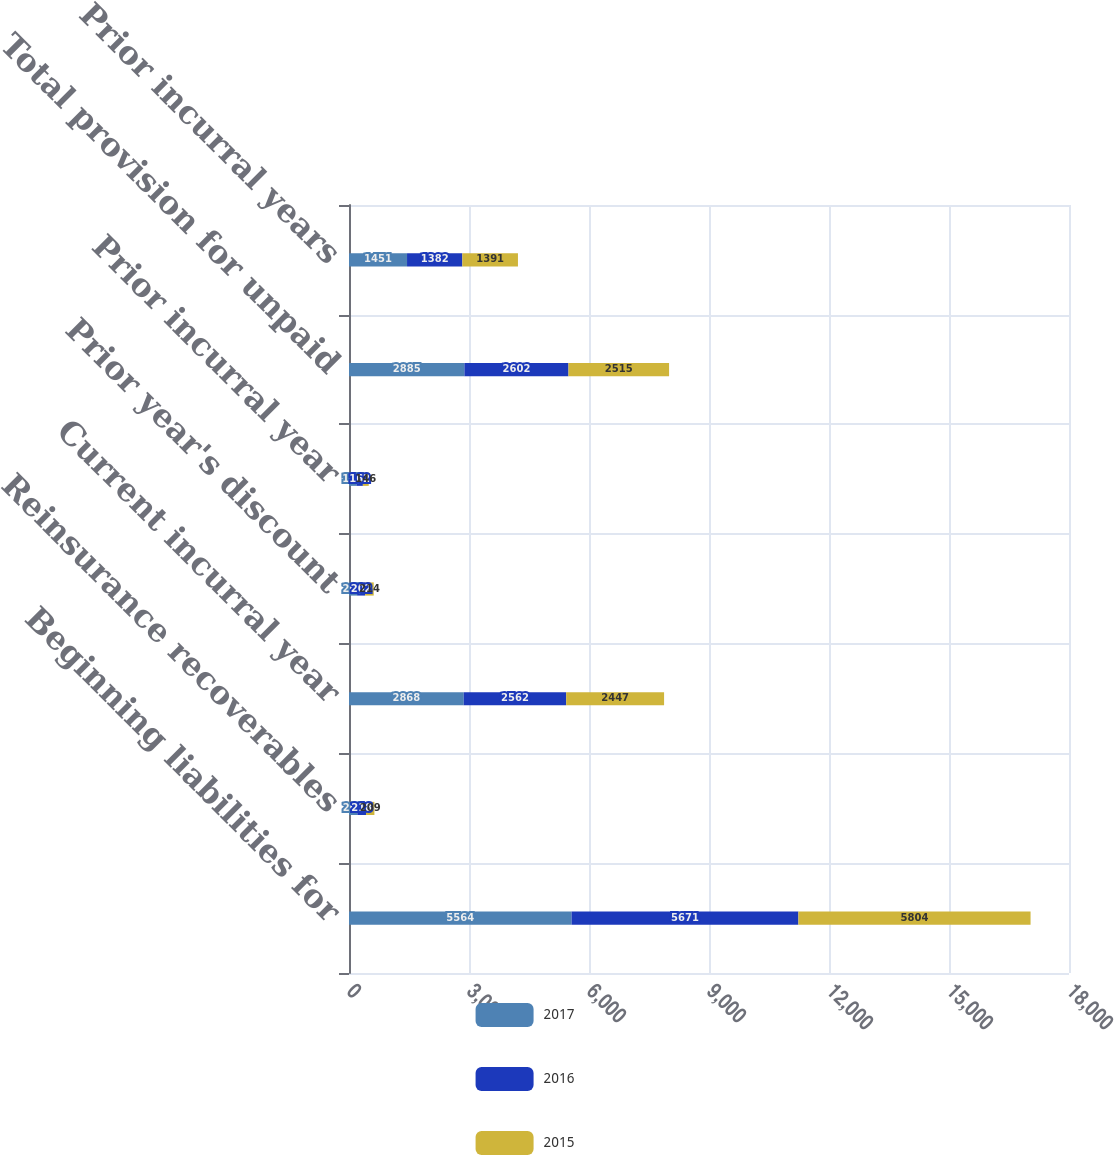<chart> <loc_0><loc_0><loc_500><loc_500><stacked_bar_chart><ecel><fcel>Beginning liabilities for<fcel>Reinsurance recoverables<fcel>Current incurral year<fcel>Prior year's discount<fcel>Prior incurral year<fcel>Total provision for unpaid<fcel>Prior incurral years<nl><fcel>2017<fcel>5564<fcel>208<fcel>2868<fcel>202<fcel>185<fcel>2885<fcel>1451<nl><fcel>2016<fcel>5671<fcel>218<fcel>2562<fcel>202<fcel>162<fcel>2602<fcel>1382<nl><fcel>2015<fcel>5804<fcel>209<fcel>2447<fcel>214<fcel>146<fcel>2515<fcel>1391<nl></chart> 